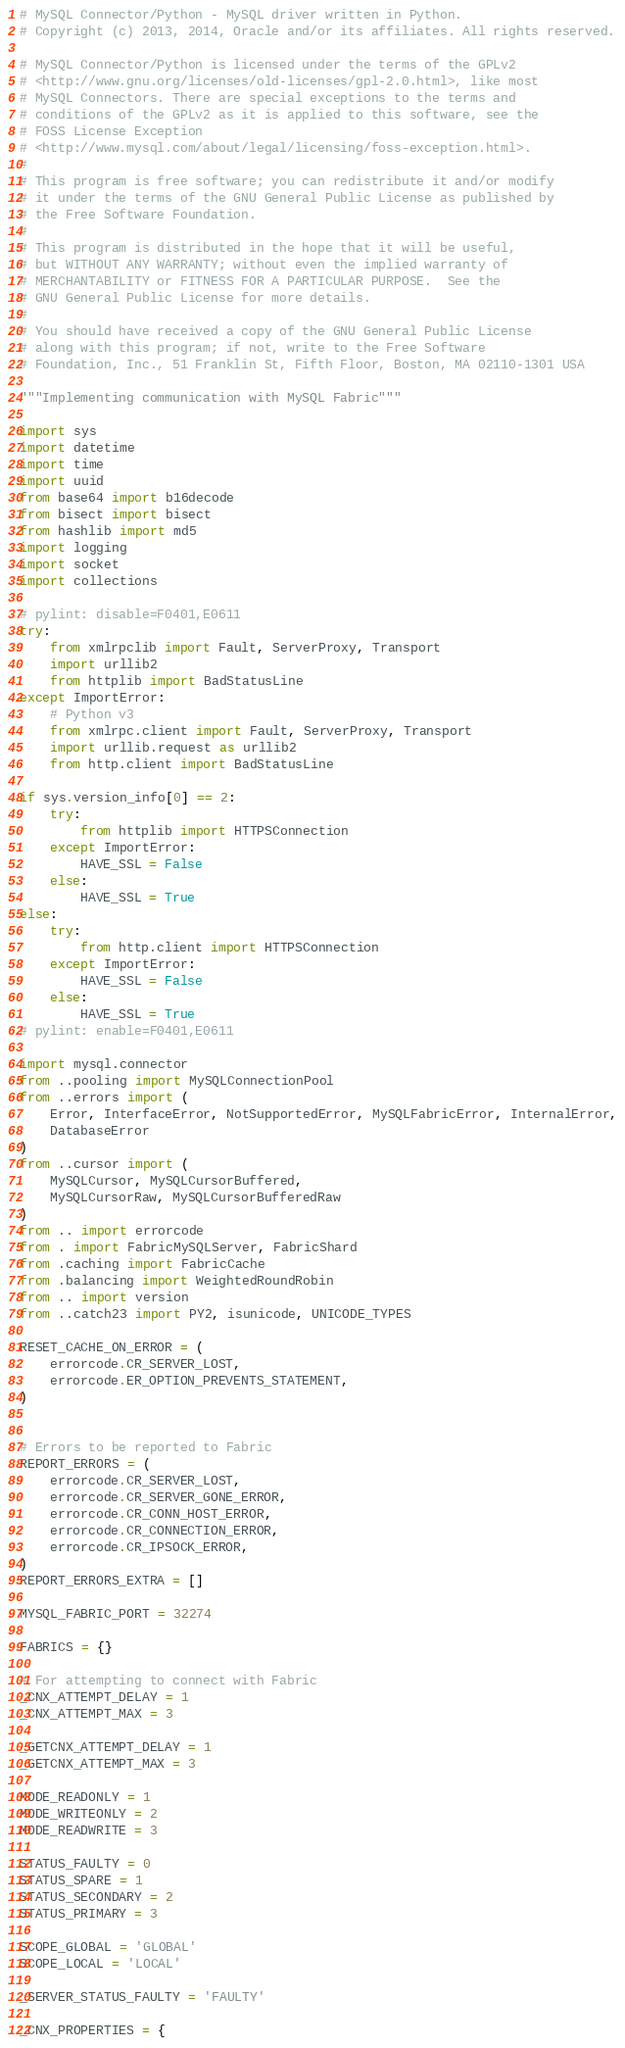Convert code to text. <code><loc_0><loc_0><loc_500><loc_500><_Python_># MySQL Connector/Python - MySQL driver written in Python.
# Copyright (c) 2013, 2014, Oracle and/or its affiliates. All rights reserved.

# MySQL Connector/Python is licensed under the terms of the GPLv2
# <http://www.gnu.org/licenses/old-licenses/gpl-2.0.html>, like most
# MySQL Connectors. There are special exceptions to the terms and
# conditions of the GPLv2 as it is applied to this software, see the
# FOSS License Exception
# <http://www.mysql.com/about/legal/licensing/foss-exception.html>.
#
# This program is free software; you can redistribute it and/or modify
# it under the terms of the GNU General Public License as published by
# the Free Software Foundation.
#
# This program is distributed in the hope that it will be useful,
# but WITHOUT ANY WARRANTY; without even the implied warranty of
# MERCHANTABILITY or FITNESS FOR A PARTICULAR PURPOSE.  See the
# GNU General Public License for more details.
#
# You should have received a copy of the GNU General Public License
# along with this program; if not, write to the Free Software
# Foundation, Inc., 51 Franklin St, Fifth Floor, Boston, MA 02110-1301 USA

"""Implementing communication with MySQL Fabric"""

import sys
import datetime
import time
import uuid
from base64 import b16decode
from bisect import bisect
from hashlib import md5
import logging
import socket
import collections

# pylint: disable=F0401,E0611
try:
    from xmlrpclib import Fault, ServerProxy, Transport
    import urllib2
    from httplib import BadStatusLine
except ImportError:
    # Python v3
    from xmlrpc.client import Fault, ServerProxy, Transport
    import urllib.request as urllib2
    from http.client import BadStatusLine

if sys.version_info[0] == 2:
    try:
        from httplib import HTTPSConnection
    except ImportError:
        HAVE_SSL = False
    else:
        HAVE_SSL = True
else:
    try:
        from http.client import HTTPSConnection
    except ImportError:
        HAVE_SSL = False
    else:
        HAVE_SSL = True
# pylint: enable=F0401,E0611

import mysql.connector
from ..pooling import MySQLConnectionPool
from ..errors import (
    Error, InterfaceError, NotSupportedError, MySQLFabricError, InternalError,
    DatabaseError
)
from ..cursor import (
    MySQLCursor, MySQLCursorBuffered,
    MySQLCursorRaw, MySQLCursorBufferedRaw
)
from .. import errorcode
from . import FabricMySQLServer, FabricShard
from .caching import FabricCache
from .balancing import WeightedRoundRobin
from .. import version
from ..catch23 import PY2, isunicode, UNICODE_TYPES

RESET_CACHE_ON_ERROR = (
    errorcode.CR_SERVER_LOST,
    errorcode.ER_OPTION_PREVENTS_STATEMENT,
)


# Errors to be reported to Fabric
REPORT_ERRORS = (
    errorcode.CR_SERVER_LOST,
    errorcode.CR_SERVER_GONE_ERROR,
    errorcode.CR_CONN_HOST_ERROR,
    errorcode.CR_CONNECTION_ERROR,
    errorcode.CR_IPSOCK_ERROR,
)
REPORT_ERRORS_EXTRA = []

MYSQL_FABRIC_PORT = 32274

FABRICS = {}

# For attempting to connect with Fabric
_CNX_ATTEMPT_DELAY = 1
_CNX_ATTEMPT_MAX = 3

_GETCNX_ATTEMPT_DELAY = 1
_GETCNX_ATTEMPT_MAX = 3

MODE_READONLY = 1
MODE_WRITEONLY = 2
MODE_READWRITE = 3

STATUS_FAULTY = 0
STATUS_SPARE = 1
STATUS_SECONDARY = 2
STATUS_PRIMARY = 3

SCOPE_GLOBAL = 'GLOBAL'
SCOPE_LOCAL = 'LOCAL'

_SERVER_STATUS_FAULTY = 'FAULTY'

_CNX_PROPERTIES = {</code> 